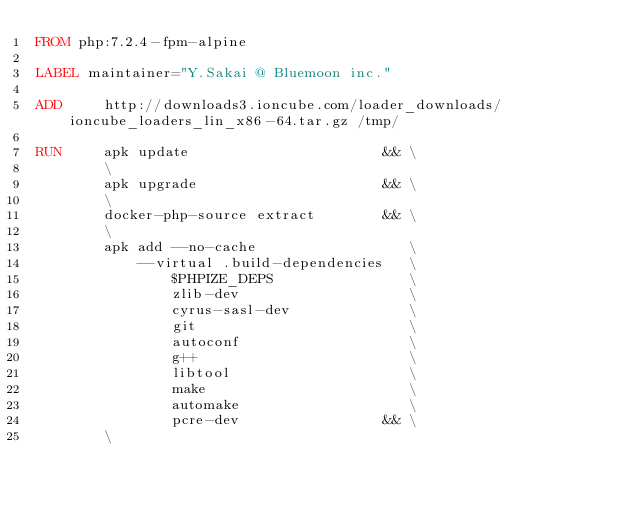Convert code to text. <code><loc_0><loc_0><loc_500><loc_500><_Dockerfile_>FROM php:7.2.4-fpm-alpine

LABEL maintainer="Y.Sakai @ Bluemoon inc."

ADD     http://downloads3.ioncube.com/loader_downloads/ioncube_loaders_lin_x86-64.tar.gz /tmp/

RUN     apk update                       && \
        \
        apk upgrade                      && \
        \
        docker-php-source extract        && \
        \
        apk add --no-cache                  \
            --virtual .build-dependencies   \
                $PHPIZE_DEPS                \
                zlib-dev                    \
                cyrus-sasl-dev              \
                git                         \
                autoconf                    \
                g++                         \
                libtool                     \
                make                        \
                automake                    \
                pcre-dev                 && \
        \</code> 